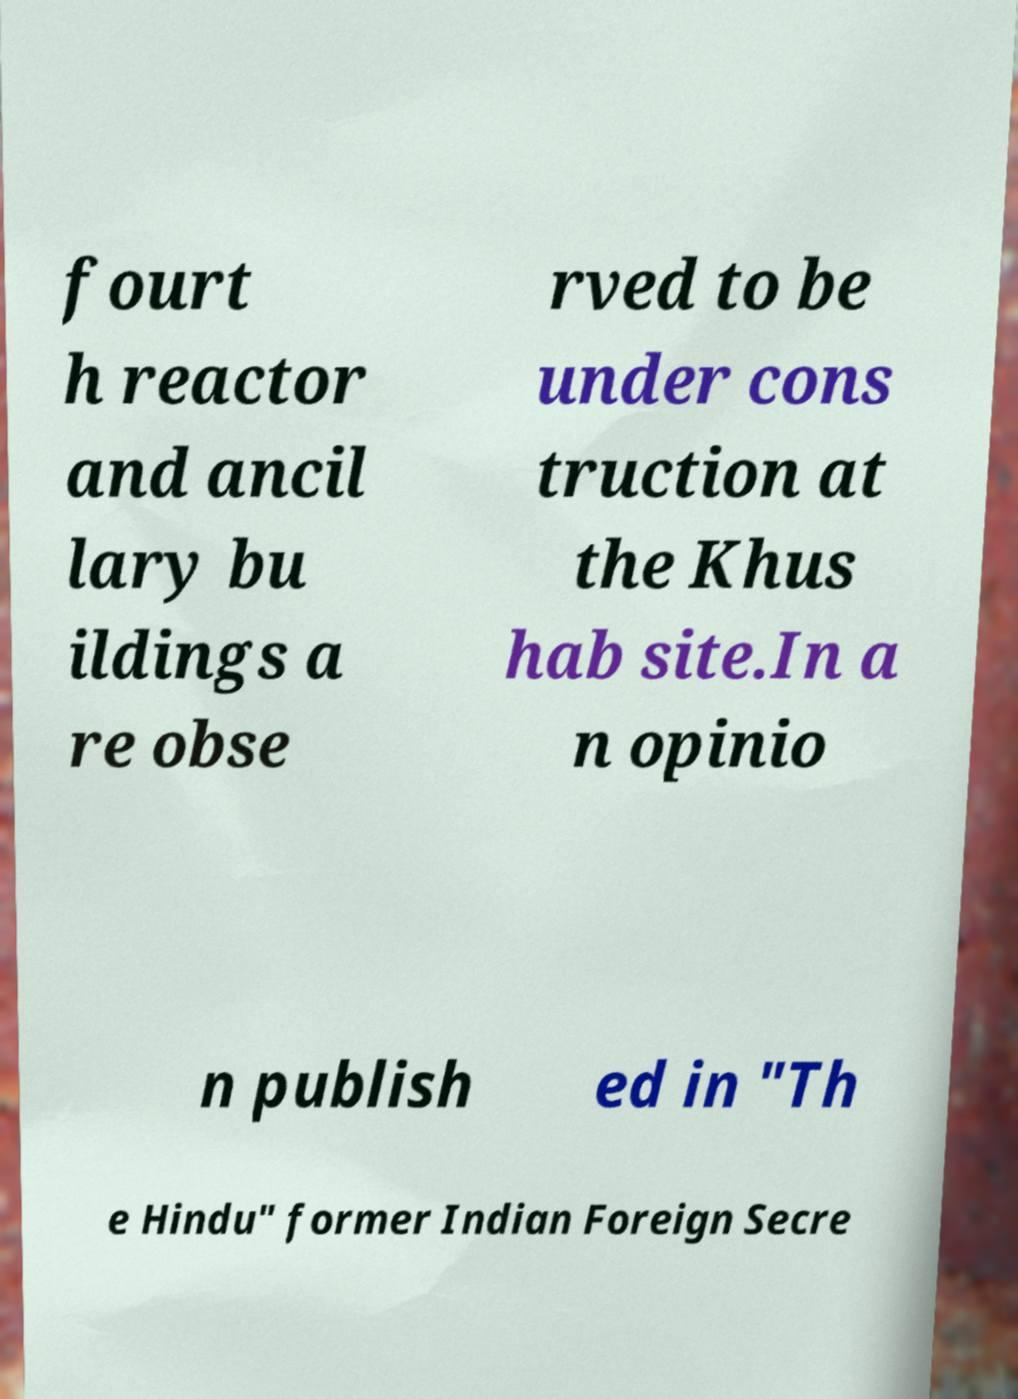I need the written content from this picture converted into text. Can you do that? fourt h reactor and ancil lary bu ildings a re obse rved to be under cons truction at the Khus hab site.In a n opinio n publish ed in "Th e Hindu" former Indian Foreign Secre 